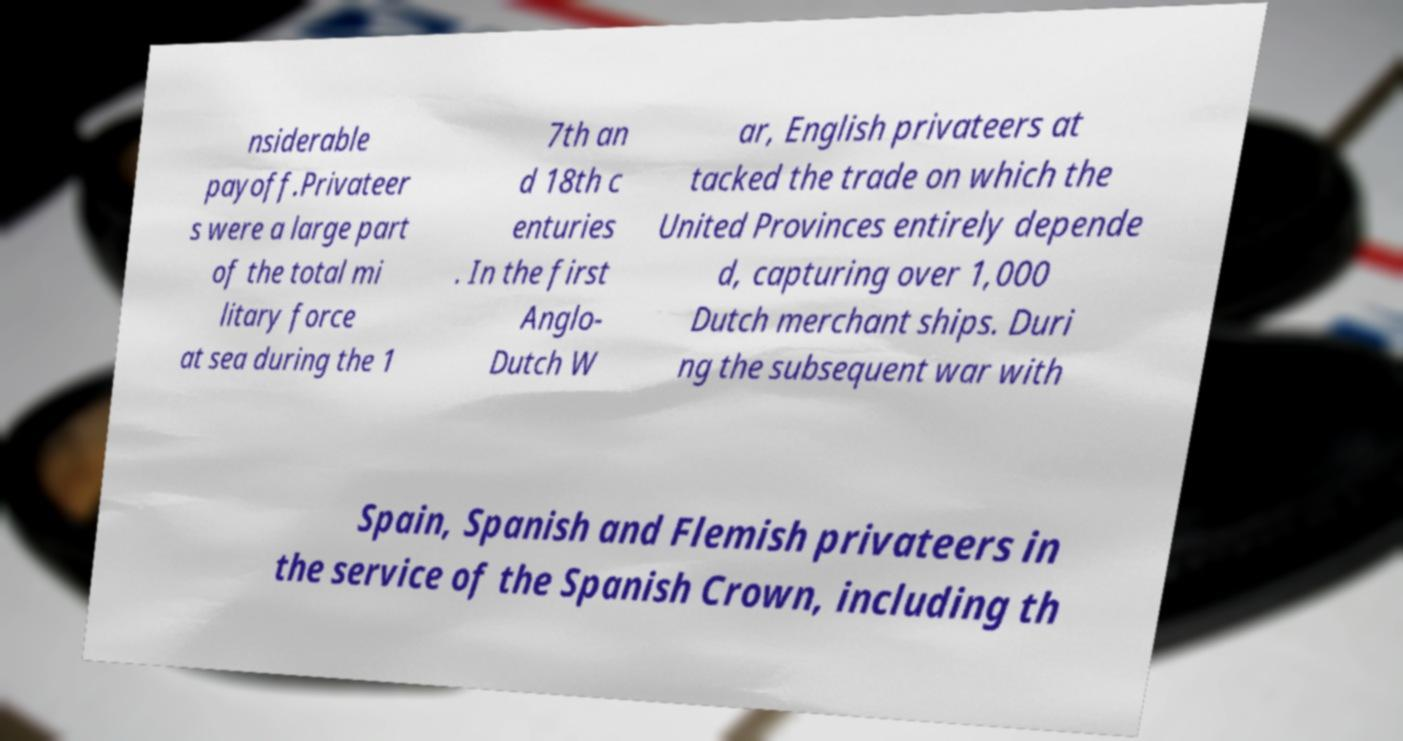Could you extract and type out the text from this image? nsiderable payoff.Privateer s were a large part of the total mi litary force at sea during the 1 7th an d 18th c enturies . In the first Anglo- Dutch W ar, English privateers at tacked the trade on which the United Provinces entirely depende d, capturing over 1,000 Dutch merchant ships. Duri ng the subsequent war with Spain, Spanish and Flemish privateers in the service of the Spanish Crown, including th 